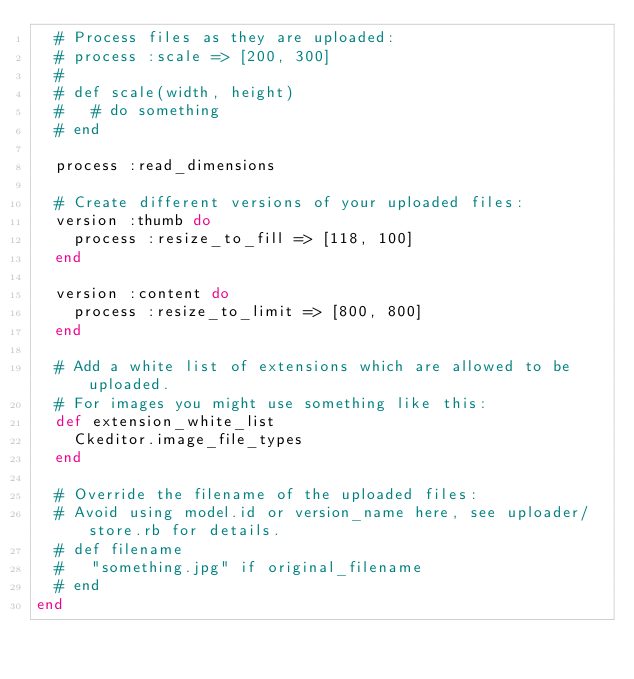Convert code to text. <code><loc_0><loc_0><loc_500><loc_500><_Ruby_>  # Process files as they are uploaded:
  # process :scale => [200, 300]
  #
  # def scale(width, height)
  #   # do something
  # end
  
  process :read_dimensions

  # Create different versions of your uploaded files:
  version :thumb do
    process :resize_to_fill => [118, 100]
  end

  version :content do
    process :resize_to_limit => [800, 800]
  end

  # Add a white list of extensions which are allowed to be uploaded.
  # For images you might use something like this:
  def extension_white_list
    Ckeditor.image_file_types
  end

  # Override the filename of the uploaded files:
  # Avoid using model.id or version_name here, see uploader/store.rb for details.
  # def filename
  #   "something.jpg" if original_filename
  # end
end
</code> 